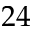<formula> <loc_0><loc_0><loc_500><loc_500>2 4</formula> 